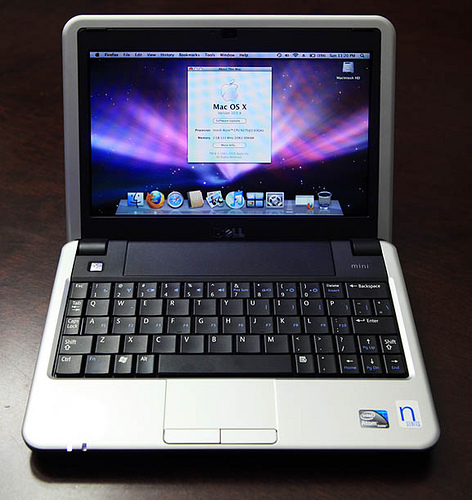<image>
Is the laptop on the table? Yes. Looking at the image, I can see the laptop is positioned on top of the table, with the table providing support. Is the computer to the left of the keyboard? No. The computer is not to the left of the keyboard. From this viewpoint, they have a different horizontal relationship. 